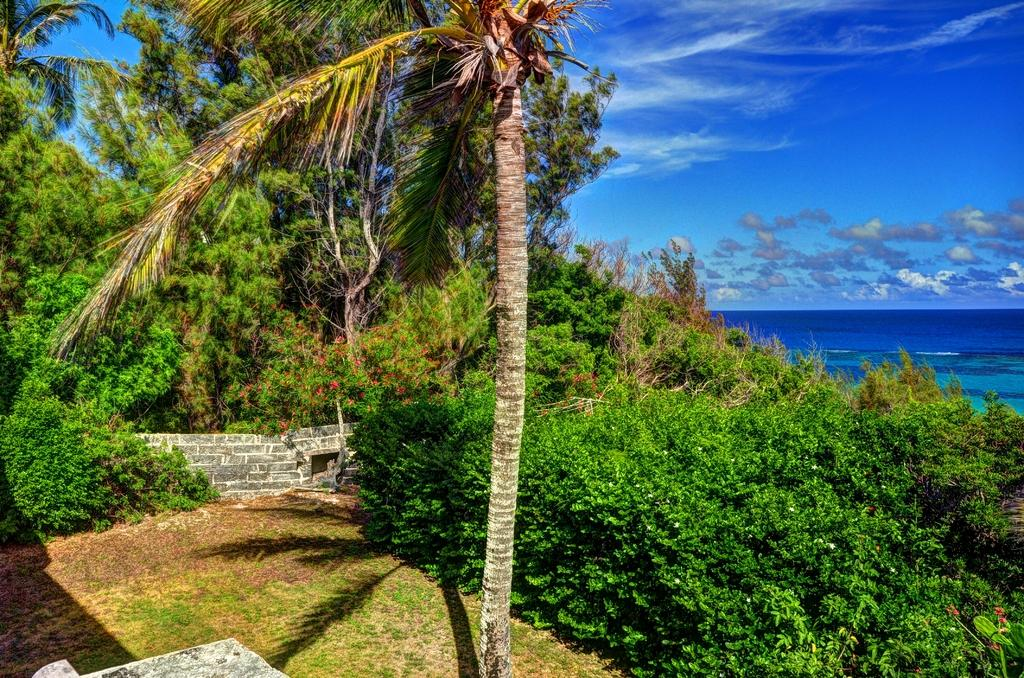What type of natural environment is depicted in the center of the image? There is greenery in the center of the image. What can be seen on the right side of the image? There is water on the right side of the image. What is visible at the top of the image? The sky is visible at the top of the image. Can you see any jelly in the image? There is no jelly present in the image. What type of teeth can be seen in the image? There are no teeth visible in the image, as it features greenery, water, and the sky. 